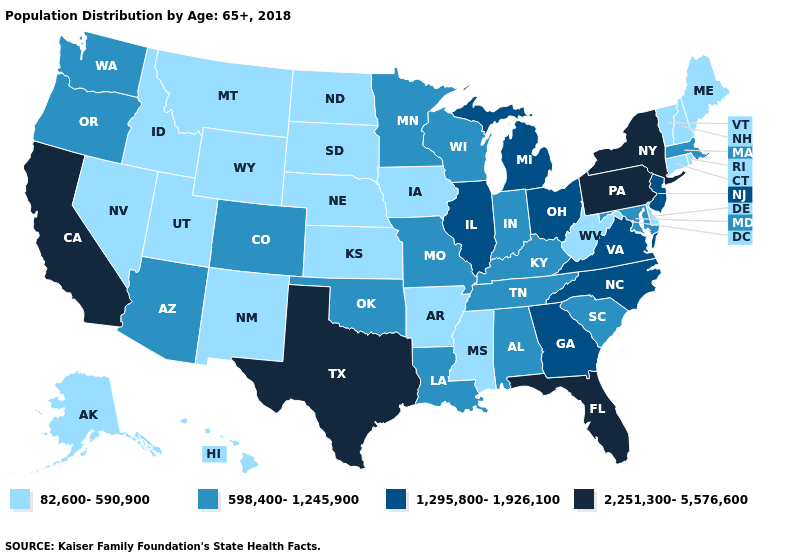What is the lowest value in states that border South Carolina?
Concise answer only. 1,295,800-1,926,100. What is the value of Connecticut?
Give a very brief answer. 82,600-590,900. Name the states that have a value in the range 1,295,800-1,926,100?
Write a very short answer. Georgia, Illinois, Michigan, New Jersey, North Carolina, Ohio, Virginia. Which states have the lowest value in the South?
Short answer required. Arkansas, Delaware, Mississippi, West Virginia. What is the lowest value in states that border Washington?
Be succinct. 82,600-590,900. What is the value of New Mexico?
Give a very brief answer. 82,600-590,900. Among the states that border Maine , which have the highest value?
Give a very brief answer. New Hampshire. Name the states that have a value in the range 82,600-590,900?
Short answer required. Alaska, Arkansas, Connecticut, Delaware, Hawaii, Idaho, Iowa, Kansas, Maine, Mississippi, Montana, Nebraska, Nevada, New Hampshire, New Mexico, North Dakota, Rhode Island, South Dakota, Utah, Vermont, West Virginia, Wyoming. What is the value of Minnesota?
Answer briefly. 598,400-1,245,900. Does Nebraska have the lowest value in the MidWest?
Answer briefly. Yes. Which states hav the highest value in the Northeast?
Write a very short answer. New York, Pennsylvania. Name the states that have a value in the range 2,251,300-5,576,600?
Keep it brief. California, Florida, New York, Pennsylvania, Texas. What is the value of New York?
Concise answer only. 2,251,300-5,576,600. Which states hav the highest value in the South?
Short answer required. Florida, Texas. 